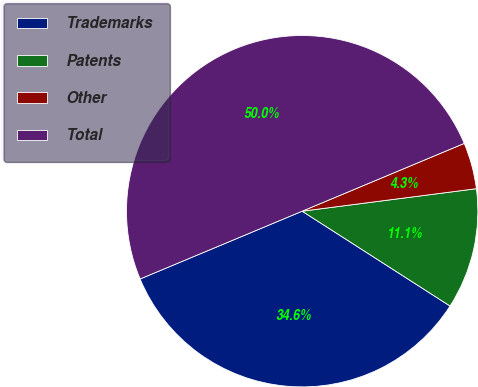<chart> <loc_0><loc_0><loc_500><loc_500><pie_chart><fcel>Trademarks<fcel>Patents<fcel>Other<fcel>Total<nl><fcel>34.62%<fcel>11.12%<fcel>4.26%<fcel>50.0%<nl></chart> 